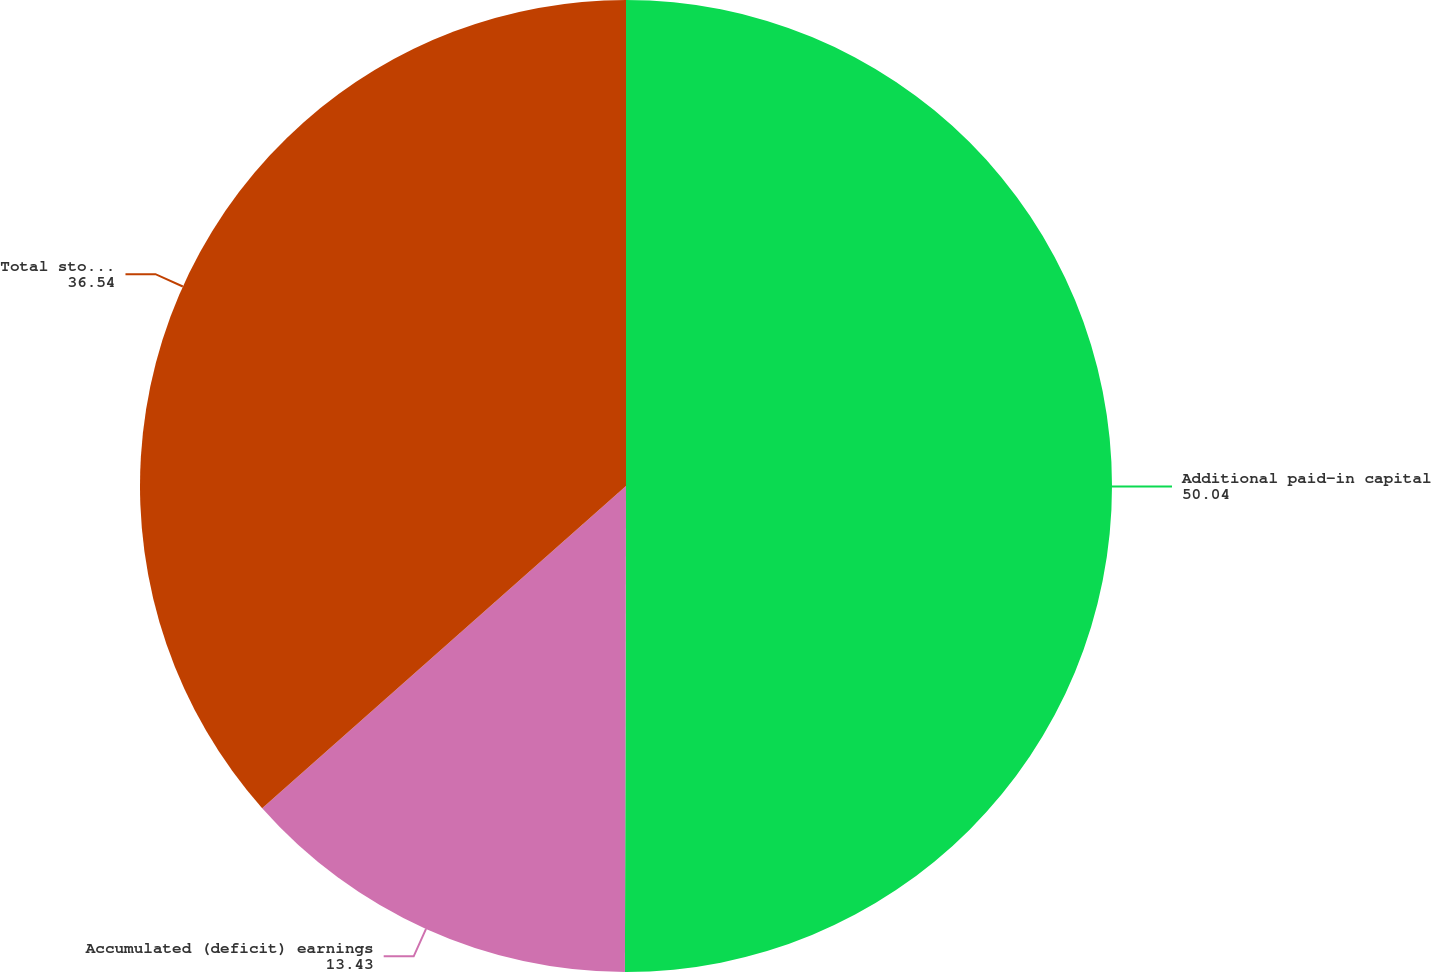Convert chart to OTSL. <chart><loc_0><loc_0><loc_500><loc_500><pie_chart><fcel>Additional paid-in capital<fcel>Accumulated (deficit) earnings<fcel>Total stockholders' equity<nl><fcel>50.04%<fcel>13.43%<fcel>36.54%<nl></chart> 